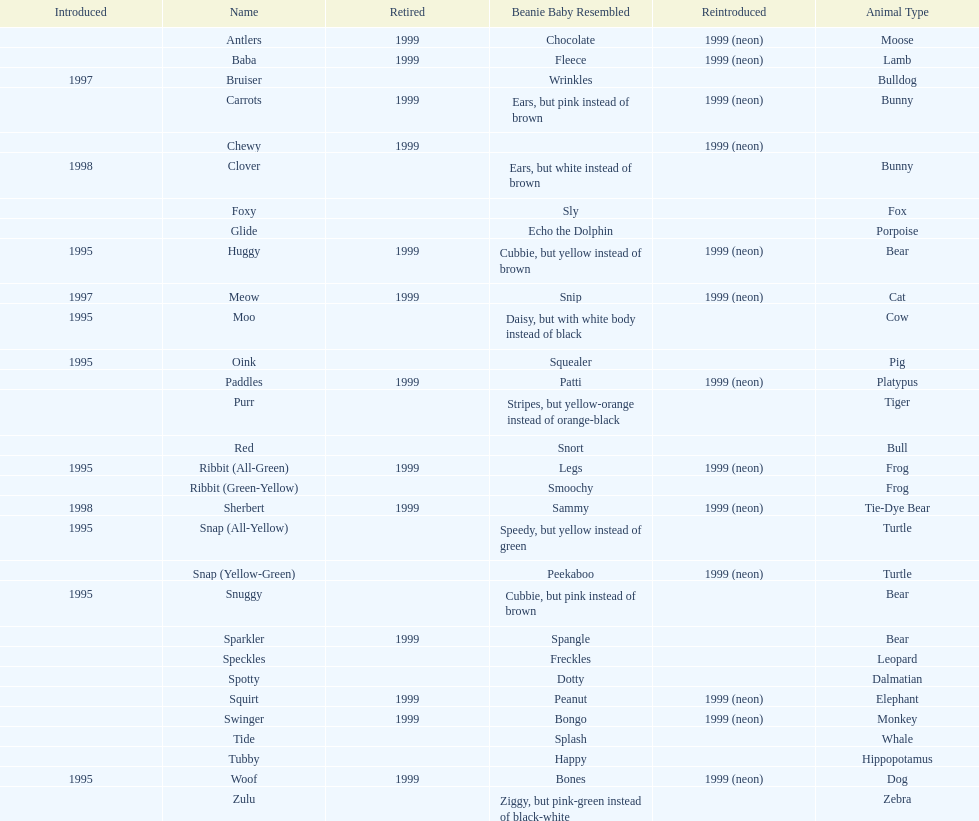Provide the count of pillow pals re-introduced in 199 13. Would you be able to parse every entry in this table? {'header': ['Introduced', 'Name', 'Retired', 'Beanie Baby Resembled', 'Reintroduced', 'Animal Type'], 'rows': [['', 'Antlers', '1999', 'Chocolate', '1999 (neon)', 'Moose'], ['', 'Baba', '1999', 'Fleece', '1999 (neon)', 'Lamb'], ['1997', 'Bruiser', '', 'Wrinkles', '', 'Bulldog'], ['', 'Carrots', '1999', 'Ears, but pink instead of brown', '1999 (neon)', 'Bunny'], ['', 'Chewy', '1999', '', '1999 (neon)', ''], ['1998', 'Clover', '', 'Ears, but white instead of brown', '', 'Bunny'], ['', 'Foxy', '', 'Sly', '', 'Fox'], ['', 'Glide', '', 'Echo the Dolphin', '', 'Porpoise'], ['1995', 'Huggy', '1999', 'Cubbie, but yellow instead of brown', '1999 (neon)', 'Bear'], ['1997', 'Meow', '1999', 'Snip', '1999 (neon)', 'Cat'], ['1995', 'Moo', '', 'Daisy, but with white body instead of black', '', 'Cow'], ['1995', 'Oink', '', 'Squealer', '', 'Pig'], ['', 'Paddles', '1999', 'Patti', '1999 (neon)', 'Platypus'], ['', 'Purr', '', 'Stripes, but yellow-orange instead of orange-black', '', 'Tiger'], ['', 'Red', '', 'Snort', '', 'Bull'], ['1995', 'Ribbit (All-Green)', '1999', 'Legs', '1999 (neon)', 'Frog'], ['', 'Ribbit (Green-Yellow)', '', 'Smoochy', '', 'Frog'], ['1998', 'Sherbert', '1999', 'Sammy', '1999 (neon)', 'Tie-Dye Bear'], ['1995', 'Snap (All-Yellow)', '', 'Speedy, but yellow instead of green', '', 'Turtle'], ['', 'Snap (Yellow-Green)', '', 'Peekaboo', '1999 (neon)', 'Turtle'], ['1995', 'Snuggy', '', 'Cubbie, but pink instead of brown', '', 'Bear'], ['', 'Sparkler', '1999', 'Spangle', '', 'Bear'], ['', 'Speckles', '', 'Freckles', '', 'Leopard'], ['', 'Spotty', '', 'Dotty', '', 'Dalmatian'], ['', 'Squirt', '1999', 'Peanut', '1999 (neon)', 'Elephant'], ['', 'Swinger', '1999', 'Bongo', '1999 (neon)', 'Monkey'], ['', 'Tide', '', 'Splash', '', 'Whale'], ['', 'Tubby', '', 'Happy', '', 'Hippopotamus'], ['1995', 'Woof', '1999', 'Bones', '1999 (neon)', 'Dog'], ['', 'Zulu', '', 'Ziggy, but pink-green instead of black-white', '', 'Zebra']]} 